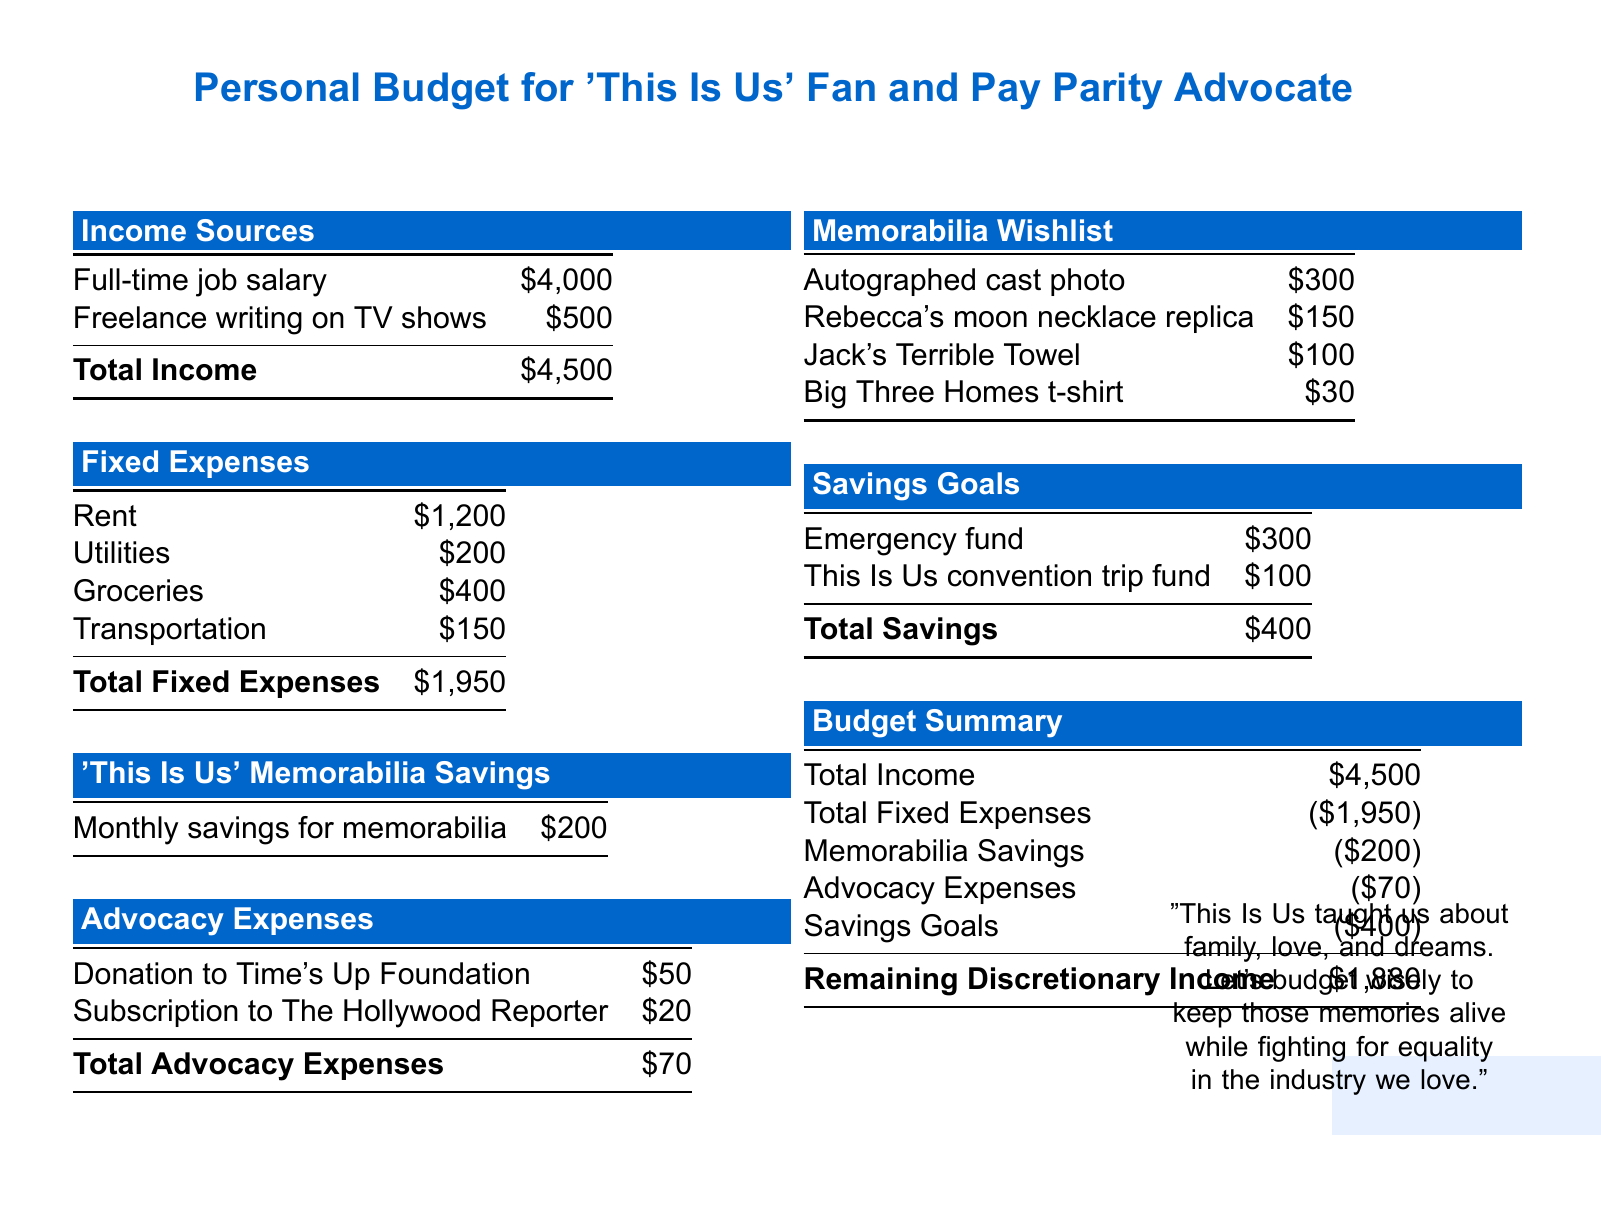What is the total income? The total income is the sum of all income sources in the document, which is $4000 + $500 = $4500.
Answer: $4500 What is the amount saved monthly for memorabilia? The monthly savings for memorabilia is specified in the 'This Is Us' Memorabilia Savings section, which is $200.
Answer: $200 How much is spent on utilities? The amount spent on utilities is detailed in the Fixed Expenses section, listed as $200.
Answer: $200 What is the cost of an autographed cast photo? The cost of an autographed cast photo is shown in the Memorabilia Wishlist, which is $300.
Answer: $300 What is the total amount allocated for advocacy expenses? The total advocacy expenses are calculated by adding the donation and subscription costs, which sum up to $50 + $20 = $70.
Answer: $70 What is the remaining discretionary income? The remaining discretionary income is calculated after deducting all expenses from total income, resulting in $1880.
Answer: $1880 What is the total amount set aside for savings goals? The total savings listed in the Savings Goals section is $400, which includes contributions to the emergency fund and convention trip fund.
Answer: $400 How much is budgeted for the This Is Us convention trip fund? The budget for the This Is Us convention trip fund is mentioned in the Savings Goals section as $100.
Answer: $100 What is the total fixed expenses? The total fixed expenses are calculated from the specific amounts in the Fixed Expenses section, which total $1950.
Answer: $1950 